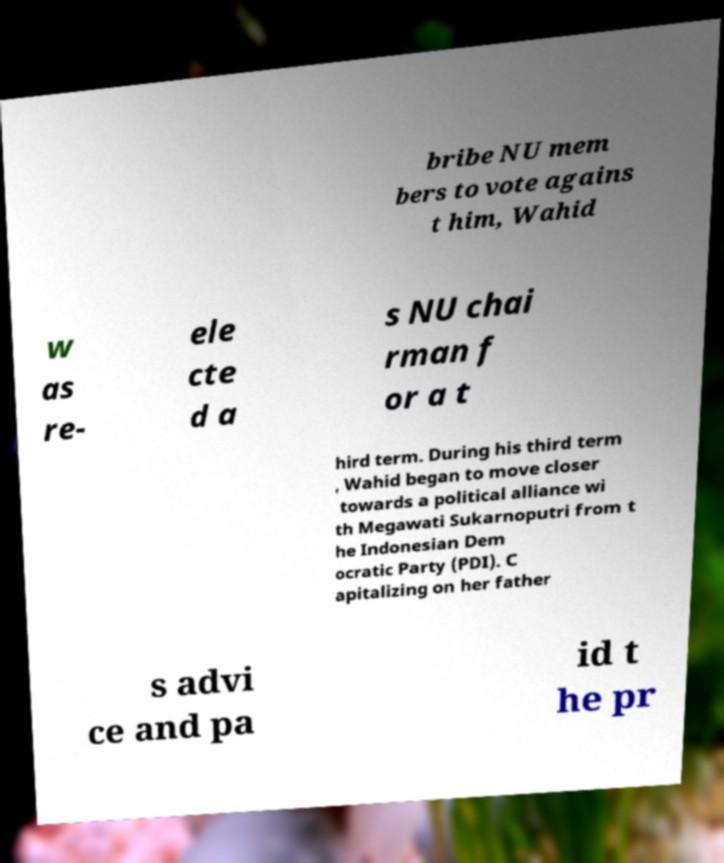Please read and relay the text visible in this image. What does it say? bribe NU mem bers to vote agains t him, Wahid w as re- ele cte d a s NU chai rman f or a t hird term. During his third term , Wahid began to move closer towards a political alliance wi th Megawati Sukarnoputri from t he Indonesian Dem ocratic Party (PDI). C apitalizing on her father s advi ce and pa id t he pr 